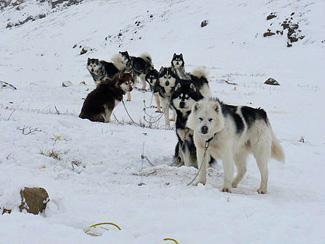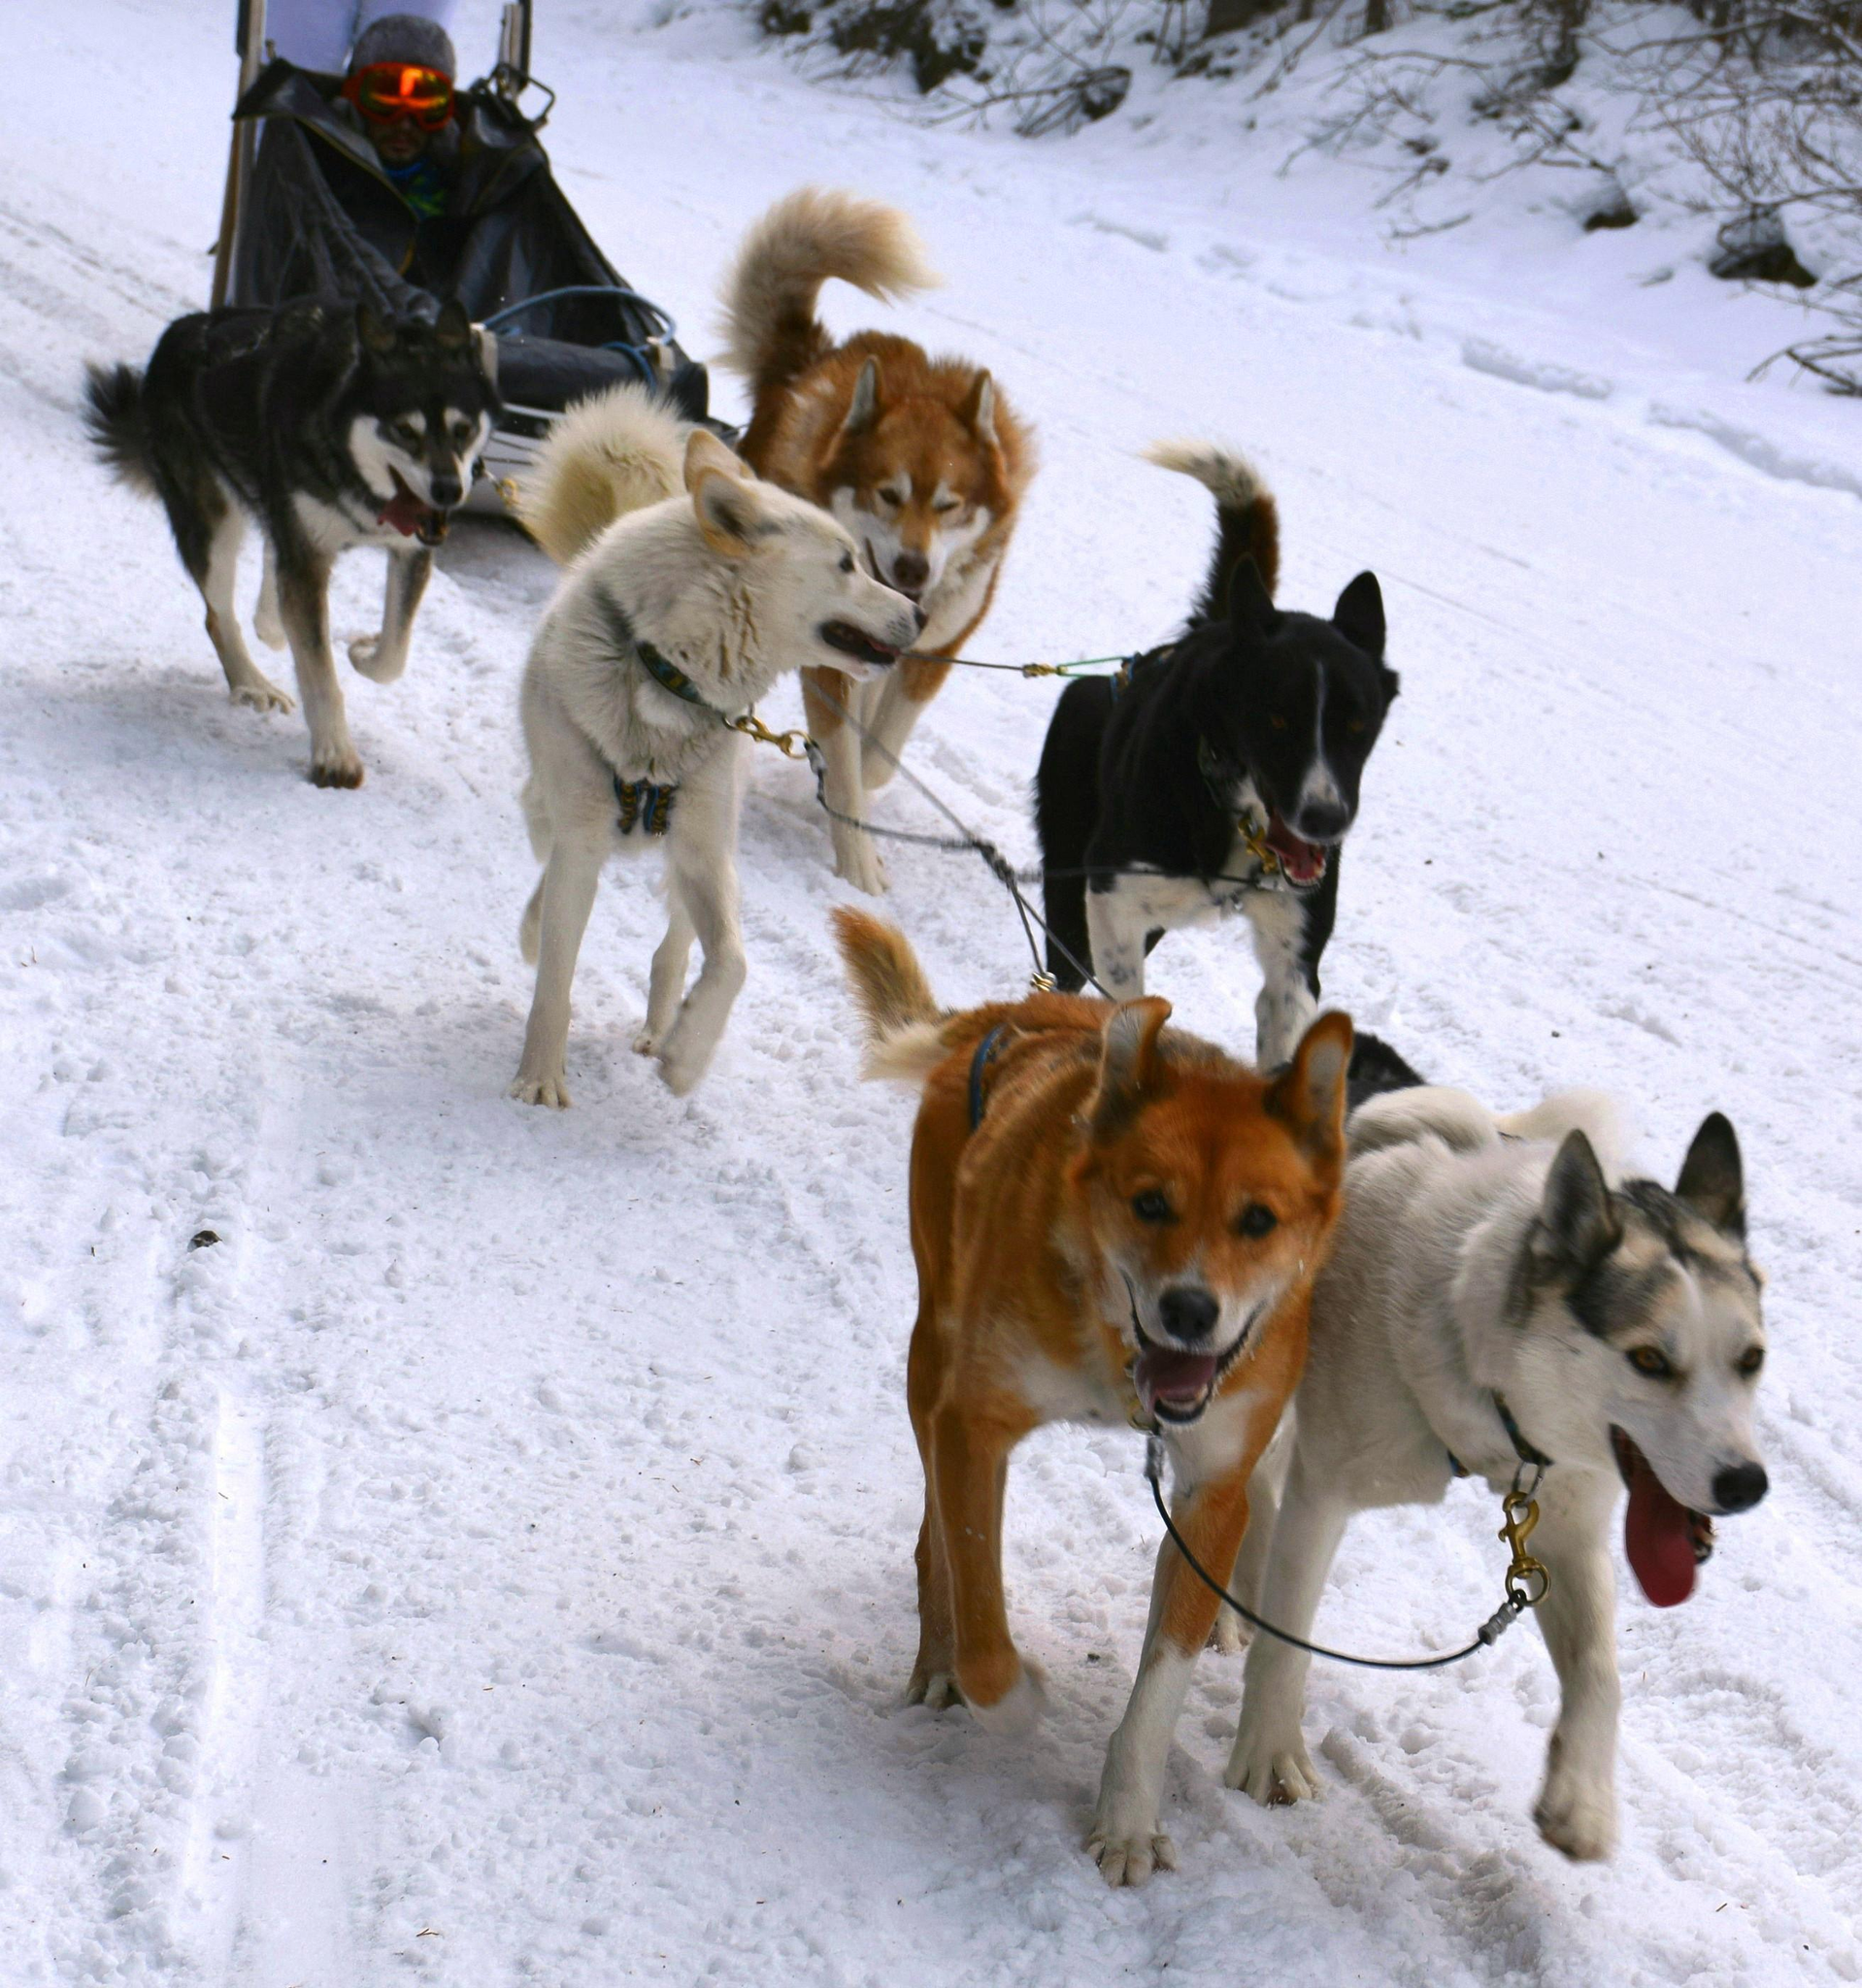The first image is the image on the left, the second image is the image on the right. For the images displayed, is the sentence "There are four huskies pulling a sled across the snow." factually correct? Answer yes or no. No. The first image is the image on the left, the second image is the image on the right. Examine the images to the left and right. Is the description "The right image shows a dog team racing forward and toward the right, and the left image shows a dog team that is not moving." accurate? Answer yes or no. Yes. 